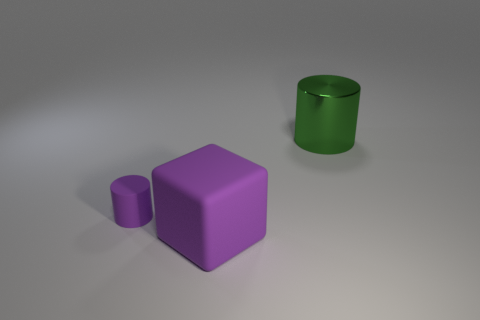How would you describe the lighting in the scene? The lighting in the image is diffuse, creating soft shadows beneath the objects, which suggests that the light source is not highly directional and may be simulating an overcast day or ambient indoor lighting. 